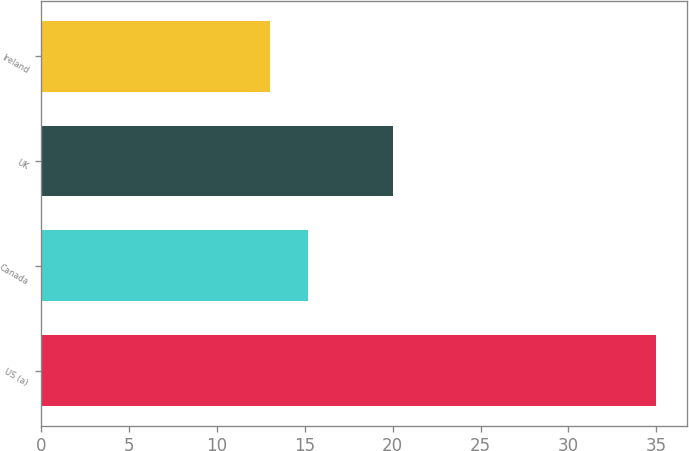<chart> <loc_0><loc_0><loc_500><loc_500><bar_chart><fcel>US (a)<fcel>Canada<fcel>UK<fcel>Ireland<nl><fcel>35<fcel>15.2<fcel>20<fcel>13<nl></chart> 